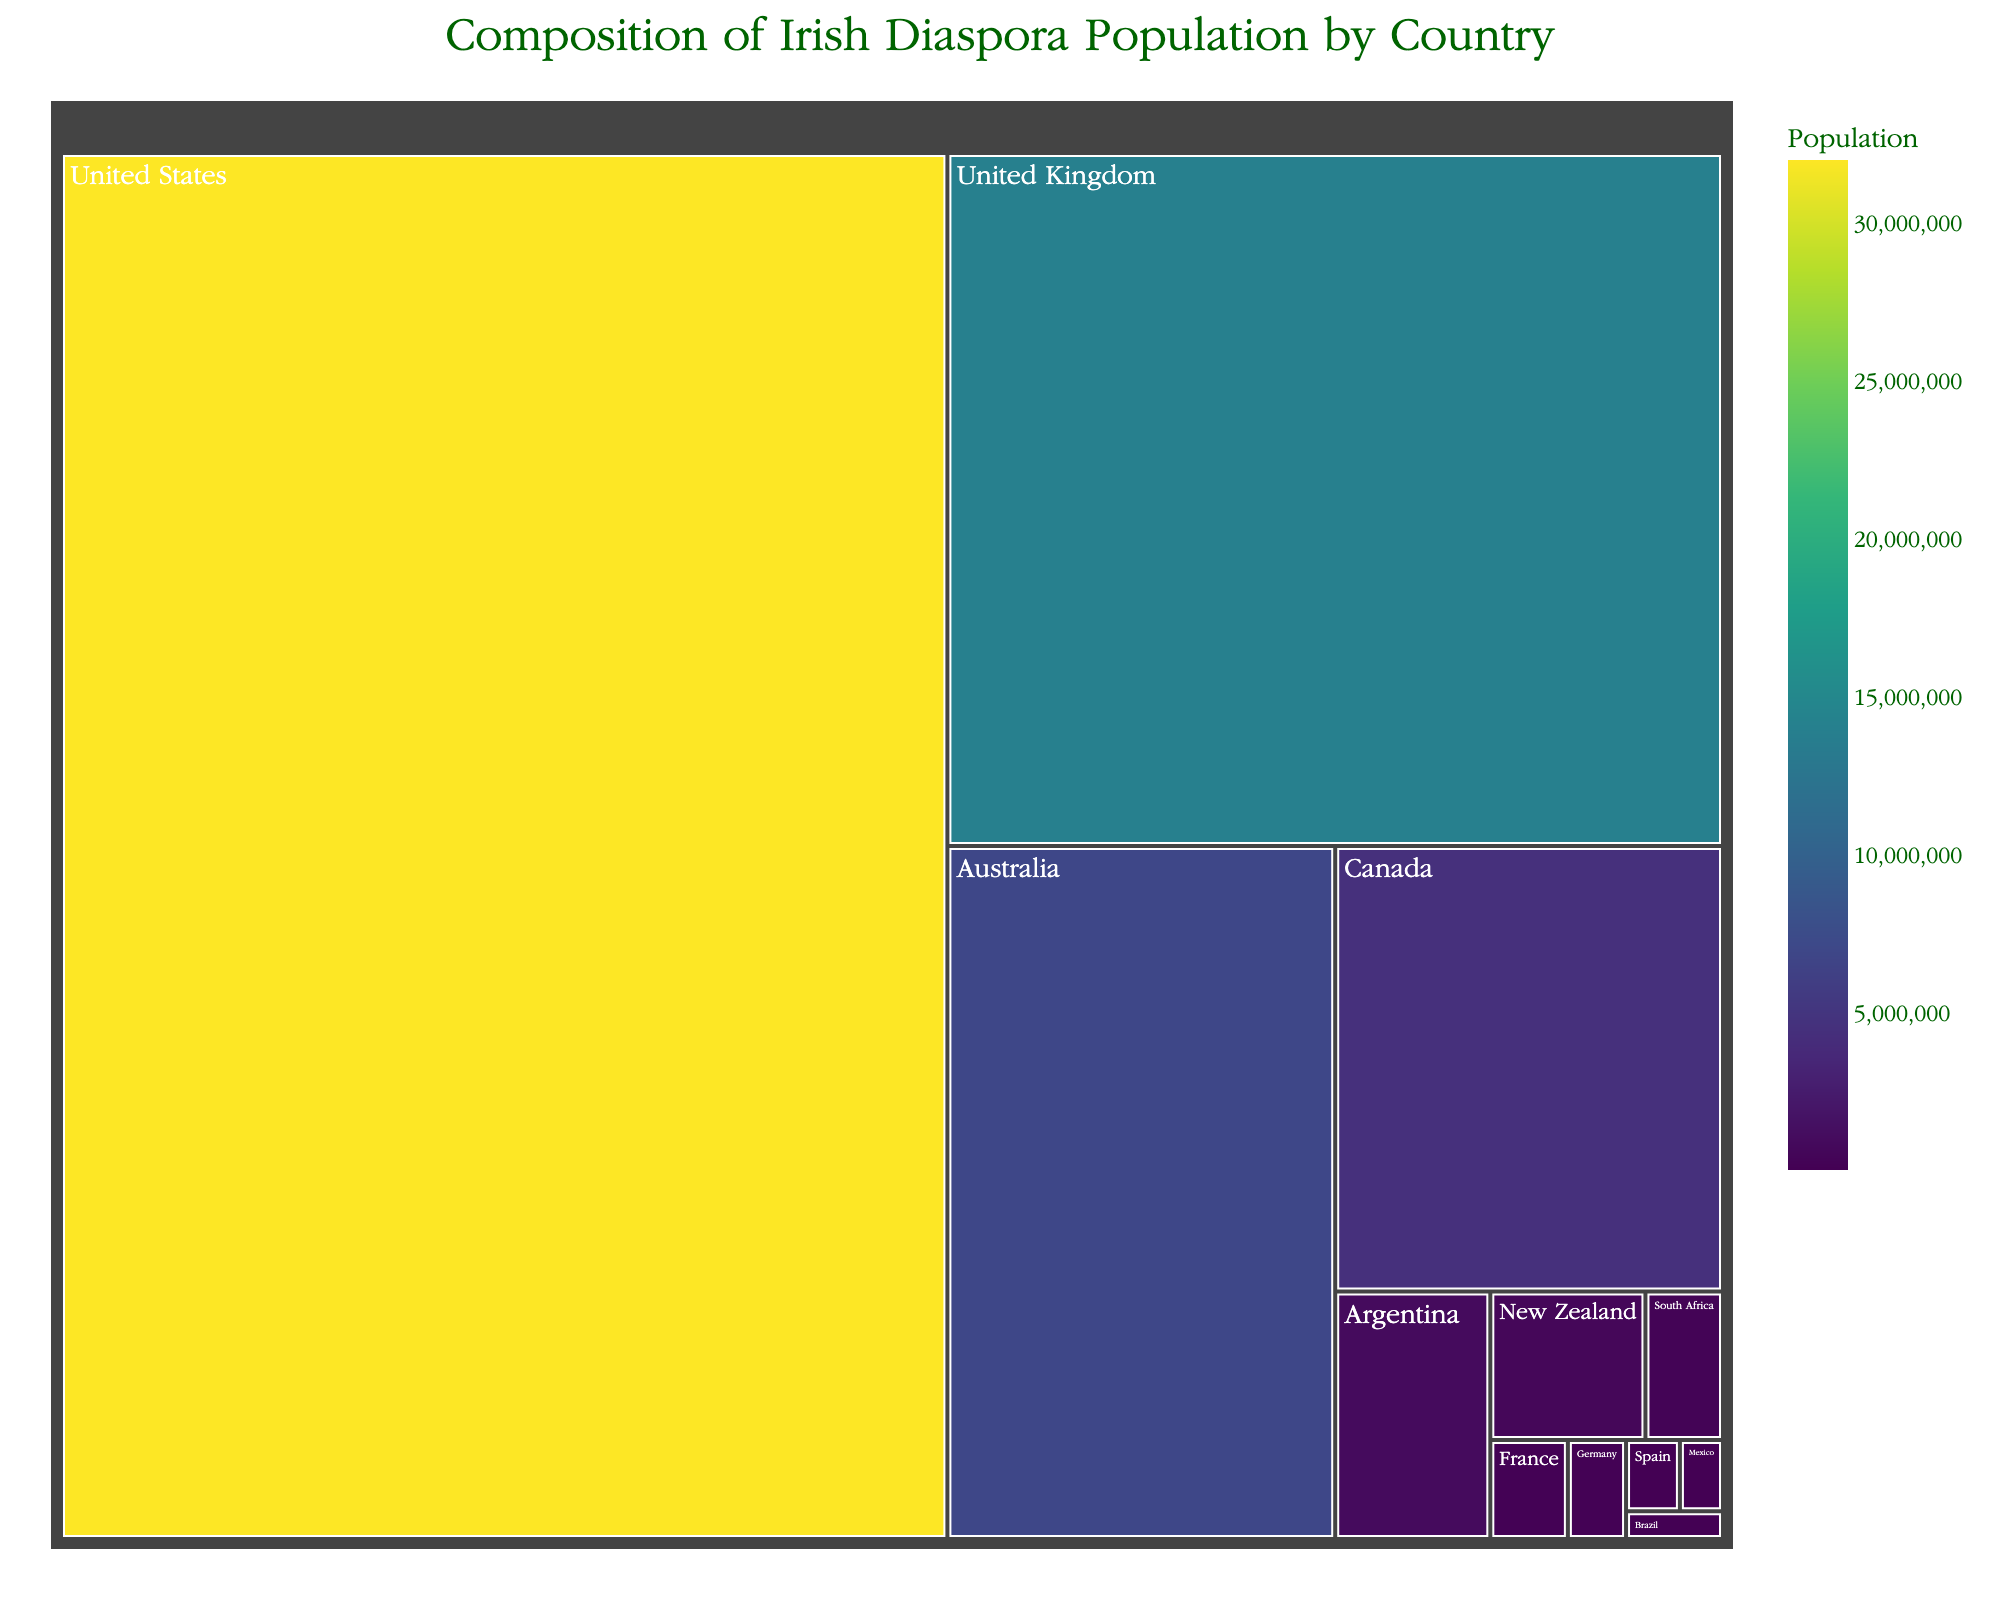What's the title of the figure? The title is prominently displayed at the top of the figure.
Answer: Composition of Irish Diaspora Population by Country Which two countries have the highest populations in the Irish diaspora? By examining the sizes of the tiles, the two largest are clearly the United States and the United Kingdom.
Answer: United States and United Kingdom What's the population of the Irish diaspora in Argentina? Hovering over Argentina's tile shows the precise population figure.
Answer: 1,000,000 How many countries have a diaspora population of over 1 million? The figure highlights populations. Checking the tiles with over 1 million reveals four countries.
Answer: Four What is the total population of the Irish diaspora in the Southern Hemisphere (Australia, New Zealand, South Africa, Argentina, Brazil)? Sum the populations of these countries: Australia (7,000,000), New Zealand (600,000), South Africa (300,000), Argentina (1,000,000), Brazil (70,000). The total is 8,970,000.
Answer: 8,970,000 Which country has the smallest population in the Irish diaspora and what is it? The smallest tile in the treemap is Brazil's, showing the population when hovered over.
Answer: Brazil, 70,000 Is the Irish diaspora population in the UK greater than in Canada and Australia combined? Compare UK's 14,000,000 with the sum of Canada’s 4,500,000 and Australia's 7,000,000. The sum of Canada and Australia is 11,500,000, which is less than 14,000,000.
Answer: Yes What color represents the highest population on the treemap, and which country does it correspond to? The color scale on the treemap indicates that the most populous countries are in a darker shade of the color scale. The darkest tile is the United States with 32,000,000.
Answer: Darkest shade, United States What's the average population across all represented countries? Sum all the populations and divide by the number of countries. Total is 59,300,000 divided by 12 countries equals approximately 4,941,667.
Answer: 4,941,667 